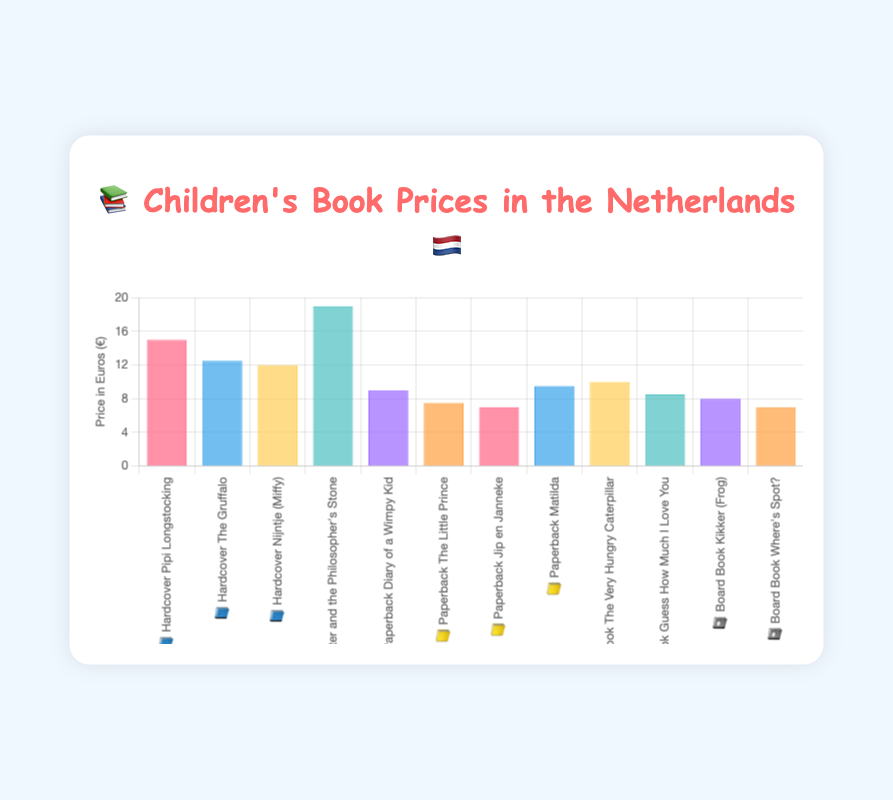What's the price of "Harry Potter and the Philosopher's Stone" in Hardcover format? You need to look for the bar labeled "📘 Hardcover Harry Potter and the Philosopher's Stone" and read the height of the bar to find the price.
Answer: 18.99 What's the lowest price for a Board Book format? Look for the smallest bar among those labeled with "📓 Board Book" and read the height of the bar to find the lowest price.
Answer: 6.99 How do the prices of "Diary of a Wimpy Kid" and "Matilda" in Paperback format compare? Compare the heights of the bars labeled "📒 Paperback Diary of a Wimpy Kid" and "📒 Paperback Matilda". You will see that "Matilda" is slightly more expensive.
Answer: Matilda is more expensive Which format has the most variation in book prices? Check the range of prices (difference between highest and lowest prices) for each format by comparing the heights of the bars within each category (📘 Hardcover, 📒 Paperback, 📓 Board Book).
Answer: Hardcover What's the average price of the books in the Hardcover format? Add the prices of all books in the "📘 Hardcover" format and divide by the number of books. (14.99 + 12.50 + 11.99 + 18.99) / 4 = 14.12
Answer: 14.12 Which book is the least expensive in the Paperback format? Find the shortest bar under the "📒 Paperback" category and read the book title associated with it.
Answer: Jip en Janneke How much more expensive is "Pipi Longstocking" in Hardcover format compared to "The Little Prince" in Paperback format? Subtract the price of "The Little Prince" from the price of "Pipi Longstocking". 14.99 - 7.50 = 7.49
Answer: 7.49 What's the highest price for a Board Book format, and which book does it correspond to? Look for the tallest bar in the "📓 Board Book" category and read the price and the book title.
Answer: 9.99, The Very Hungry Caterpillar 